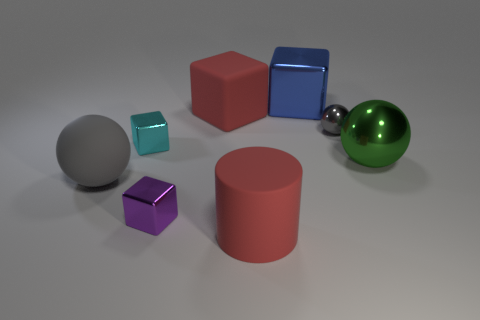There is a big red matte thing that is in front of the green shiny object; does it have the same shape as the big red matte thing that is behind the gray rubber sphere?
Your answer should be very brief. No. What number of other things are there of the same material as the tiny gray ball
Ensure brevity in your answer.  4. Are there any big red objects that are in front of the red thing that is in front of the red object that is to the left of the large matte cylinder?
Your response must be concise. No. Do the big gray ball and the small cyan cube have the same material?
Ensure brevity in your answer.  No. Is there any other thing that has the same shape as the small cyan metallic thing?
Give a very brief answer. Yes. What is the thing behind the large red thing that is behind the matte cylinder made of?
Offer a very short reply. Metal. There is a red thing behind the large red rubber cylinder; how big is it?
Keep it short and to the point. Large. There is a thing that is behind the big matte cylinder and in front of the big matte sphere; what is its color?
Your answer should be very brief. Purple. There is a ball on the left side of the purple block; is its size the same as the cyan thing?
Your response must be concise. No. There is a large rubber cylinder in front of the large gray rubber sphere; are there any large green metal things that are in front of it?
Give a very brief answer. No. 